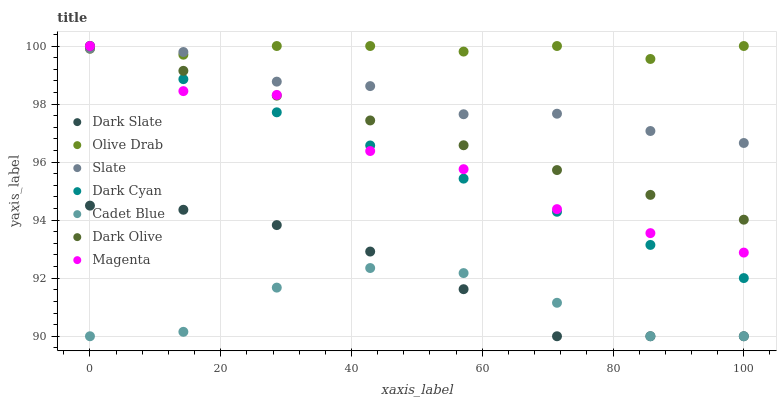Does Cadet Blue have the minimum area under the curve?
Answer yes or no. Yes. Does Olive Drab have the maximum area under the curve?
Answer yes or no. Yes. Does Slate have the minimum area under the curve?
Answer yes or no. No. Does Slate have the maximum area under the curve?
Answer yes or no. No. Is Dark Olive the smoothest?
Answer yes or no. Yes. Is Magenta the roughest?
Answer yes or no. Yes. Is Slate the smoothest?
Answer yes or no. No. Is Slate the roughest?
Answer yes or no. No. Does Cadet Blue have the lowest value?
Answer yes or no. Yes. Does Slate have the lowest value?
Answer yes or no. No. Does Olive Drab have the highest value?
Answer yes or no. Yes. Does Slate have the highest value?
Answer yes or no. No. Is Dark Slate less than Slate?
Answer yes or no. Yes. Is Olive Drab greater than Cadet Blue?
Answer yes or no. Yes. Does Dark Olive intersect Dark Cyan?
Answer yes or no. Yes. Is Dark Olive less than Dark Cyan?
Answer yes or no. No. Is Dark Olive greater than Dark Cyan?
Answer yes or no. No. Does Dark Slate intersect Slate?
Answer yes or no. No. 